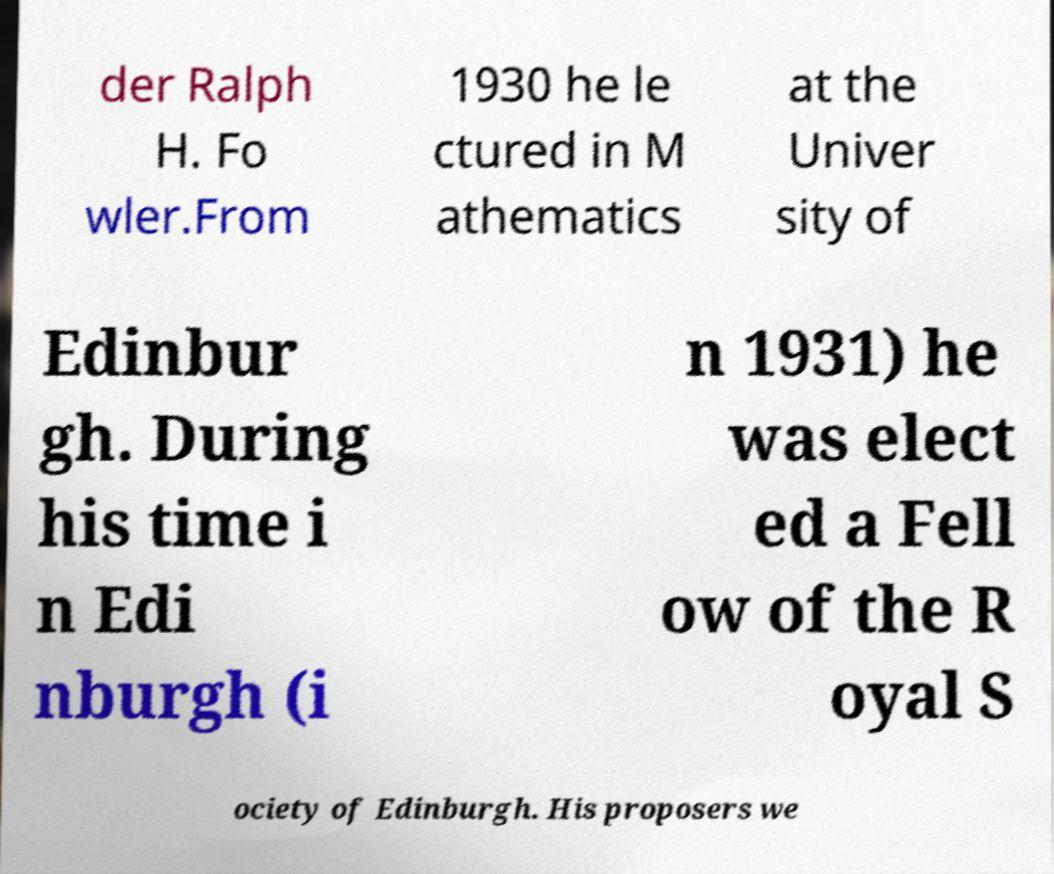There's text embedded in this image that I need extracted. Can you transcribe it verbatim? der Ralph H. Fo wler.From 1930 he le ctured in M athematics at the Univer sity of Edinbur gh. During his time i n Edi nburgh (i n 1931) he was elect ed a Fell ow of the R oyal S ociety of Edinburgh. His proposers we 